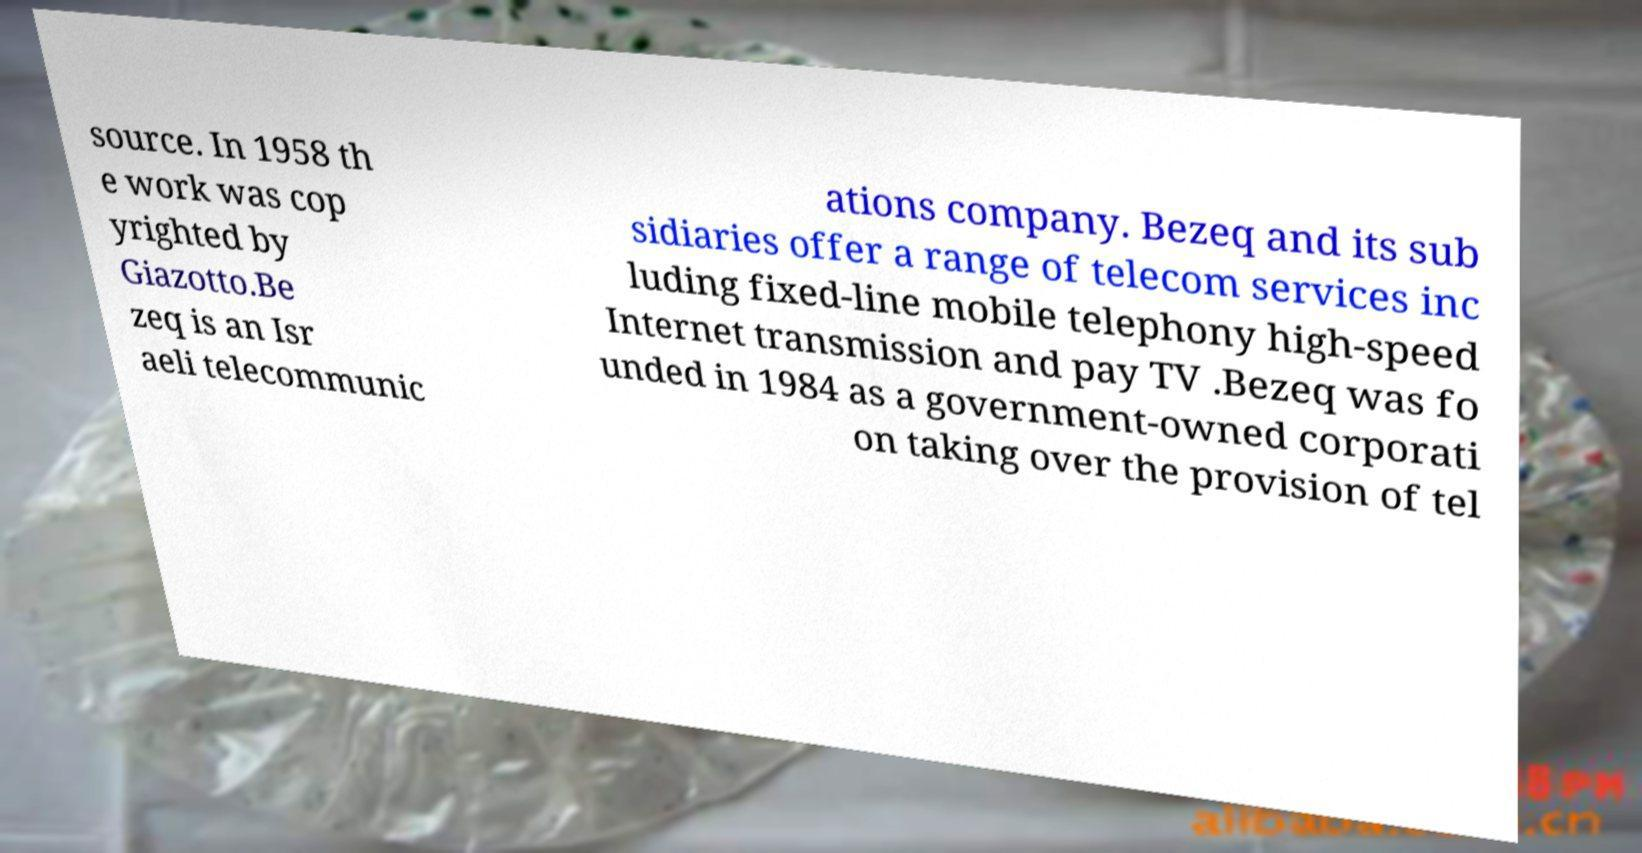There's text embedded in this image that I need extracted. Can you transcribe it verbatim? source. In 1958 th e work was cop yrighted by Giazotto.Be zeq is an Isr aeli telecommunic ations company. Bezeq and its sub sidiaries offer a range of telecom services inc luding fixed-line mobile telephony high-speed Internet transmission and pay TV .Bezeq was fo unded in 1984 as a government-owned corporati on taking over the provision of tel 